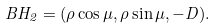<formula> <loc_0><loc_0><loc_500><loc_500>B H _ { 2 } = ( \rho \cos \mu , \rho \sin \mu , - D ) .</formula> 